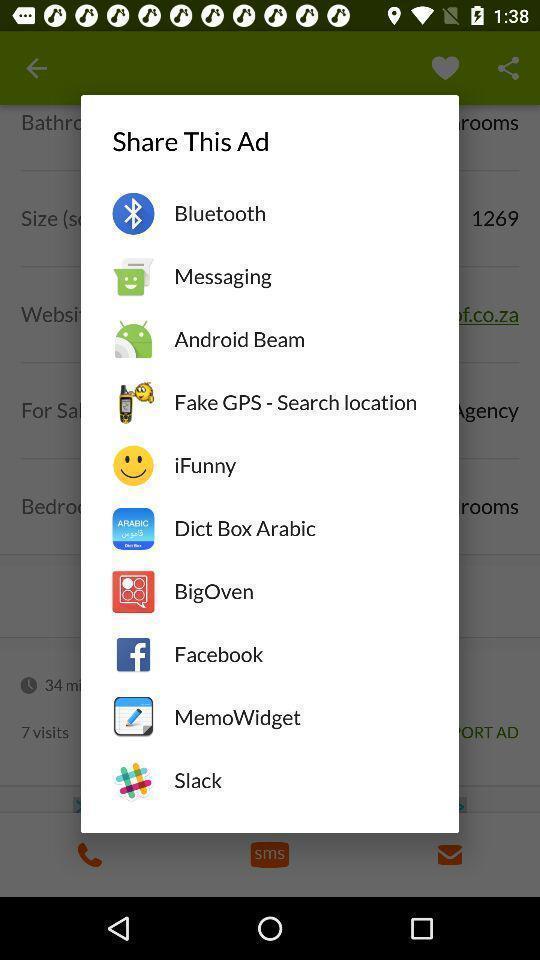Summarize the main components in this picture. Push up message to share with different kinds of services. 